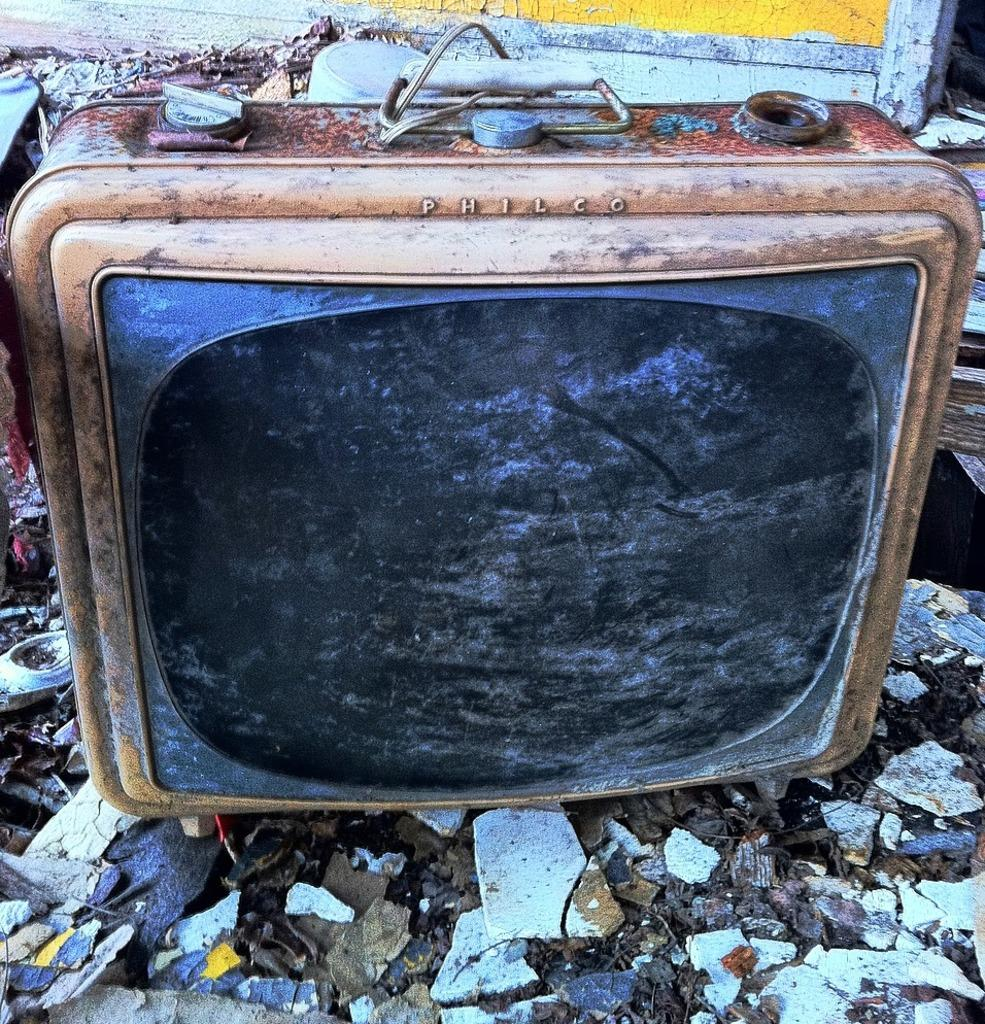What type of electronic device is in the image? There is an old television in the image. What colors can be seen on the television? The television is black and brown in color. What type of natural material is visible at the bottom of the image? There are stones visible at the bottom of the image. What type of wall can be seen in the background of the image? There is a wooden wall in the background of the image. What colors are the wooden wall? The wooden wall is white and yellow in color. What type of fruit is hanging from the television in the image? There is no fruit hanging from the television in the image. Is there a string attached to the wooden wall in the image? There is no mention of a string attached to the wooden wall in the image. 